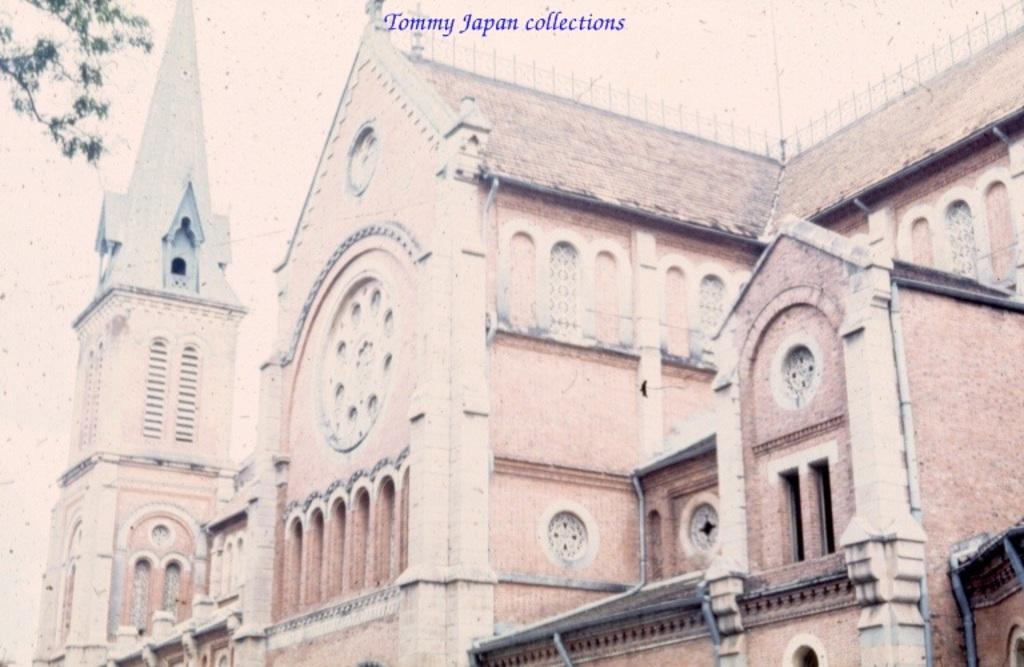What type of structures can be seen in the image? There are buildings in the image. What natural element is present in the image? There is a tree in the image. What feature can be seen on the buildings in the image? There are windows visible in the image. What type of content is present on the image? There is text present in the image. Can you see a needle threading itself in the image? There is no needle or threading activity present in the image. Is there an airplane flying over the buildings in the image? There is no airplane visible in the image. 